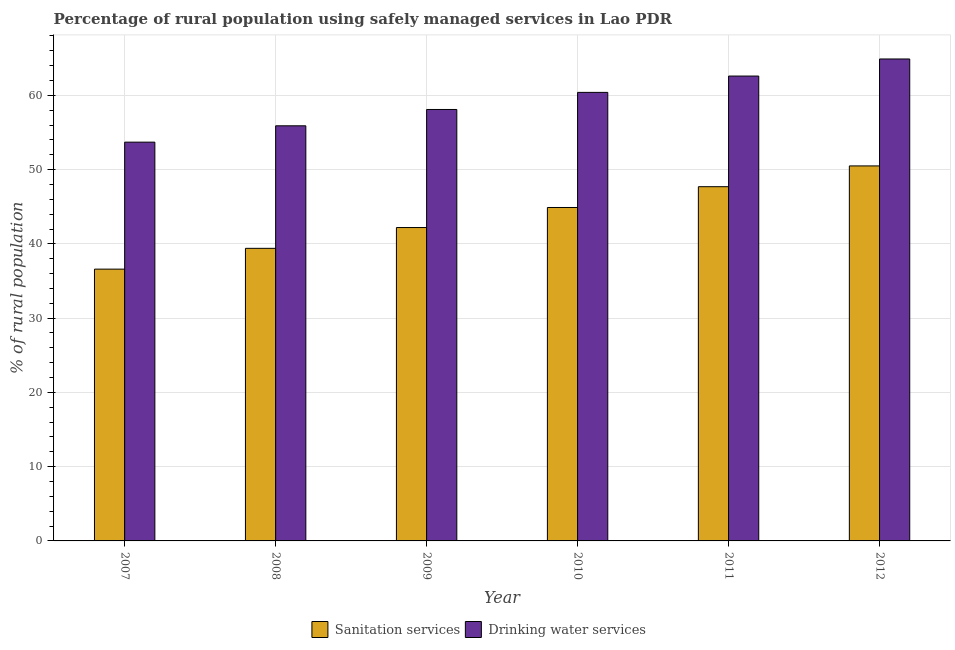How many different coloured bars are there?
Give a very brief answer. 2. Are the number of bars per tick equal to the number of legend labels?
Your answer should be very brief. Yes. Are the number of bars on each tick of the X-axis equal?
Your answer should be very brief. Yes. How many bars are there on the 3rd tick from the left?
Offer a very short reply. 2. What is the label of the 4th group of bars from the left?
Your answer should be compact. 2010. What is the percentage of rural population who used drinking water services in 2009?
Your answer should be compact. 58.1. Across all years, what is the maximum percentage of rural population who used sanitation services?
Your answer should be compact. 50.5. Across all years, what is the minimum percentage of rural population who used sanitation services?
Provide a succinct answer. 36.6. In which year was the percentage of rural population who used drinking water services minimum?
Offer a very short reply. 2007. What is the total percentage of rural population who used drinking water services in the graph?
Offer a very short reply. 355.6. What is the difference between the percentage of rural population who used sanitation services in 2007 and that in 2008?
Make the answer very short. -2.8. What is the difference between the percentage of rural population who used drinking water services in 2008 and the percentage of rural population who used sanitation services in 2007?
Give a very brief answer. 2.2. What is the average percentage of rural population who used drinking water services per year?
Keep it short and to the point. 59.27. In the year 2007, what is the difference between the percentage of rural population who used sanitation services and percentage of rural population who used drinking water services?
Make the answer very short. 0. In how many years, is the percentage of rural population who used sanitation services greater than 40 %?
Make the answer very short. 4. What is the ratio of the percentage of rural population who used sanitation services in 2008 to that in 2010?
Keep it short and to the point. 0.88. Is the percentage of rural population who used sanitation services in 2008 less than that in 2011?
Offer a very short reply. Yes. What is the difference between the highest and the second highest percentage of rural population who used sanitation services?
Give a very brief answer. 2.8. What is the difference between the highest and the lowest percentage of rural population who used sanitation services?
Ensure brevity in your answer.  13.9. In how many years, is the percentage of rural population who used drinking water services greater than the average percentage of rural population who used drinking water services taken over all years?
Your answer should be compact. 3. What does the 2nd bar from the left in 2011 represents?
Offer a terse response. Drinking water services. What does the 1st bar from the right in 2008 represents?
Give a very brief answer. Drinking water services. Are all the bars in the graph horizontal?
Offer a terse response. No. How many years are there in the graph?
Give a very brief answer. 6. Are the values on the major ticks of Y-axis written in scientific E-notation?
Your response must be concise. No. How many legend labels are there?
Give a very brief answer. 2. What is the title of the graph?
Keep it short and to the point. Percentage of rural population using safely managed services in Lao PDR. What is the label or title of the X-axis?
Your answer should be very brief. Year. What is the label or title of the Y-axis?
Provide a succinct answer. % of rural population. What is the % of rural population in Sanitation services in 2007?
Your answer should be compact. 36.6. What is the % of rural population in Drinking water services in 2007?
Your answer should be very brief. 53.7. What is the % of rural population of Sanitation services in 2008?
Offer a very short reply. 39.4. What is the % of rural population in Drinking water services in 2008?
Keep it short and to the point. 55.9. What is the % of rural population in Sanitation services in 2009?
Provide a short and direct response. 42.2. What is the % of rural population in Drinking water services in 2009?
Provide a short and direct response. 58.1. What is the % of rural population of Sanitation services in 2010?
Your answer should be very brief. 44.9. What is the % of rural population in Drinking water services in 2010?
Ensure brevity in your answer.  60.4. What is the % of rural population in Sanitation services in 2011?
Your response must be concise. 47.7. What is the % of rural population of Drinking water services in 2011?
Keep it short and to the point. 62.6. What is the % of rural population of Sanitation services in 2012?
Offer a terse response. 50.5. What is the % of rural population in Drinking water services in 2012?
Your answer should be very brief. 64.9. Across all years, what is the maximum % of rural population in Sanitation services?
Provide a succinct answer. 50.5. Across all years, what is the maximum % of rural population in Drinking water services?
Provide a succinct answer. 64.9. Across all years, what is the minimum % of rural population in Sanitation services?
Provide a succinct answer. 36.6. Across all years, what is the minimum % of rural population in Drinking water services?
Keep it short and to the point. 53.7. What is the total % of rural population in Sanitation services in the graph?
Keep it short and to the point. 261.3. What is the total % of rural population in Drinking water services in the graph?
Your answer should be compact. 355.6. What is the difference between the % of rural population in Drinking water services in 2007 and that in 2008?
Offer a very short reply. -2.2. What is the difference between the % of rural population in Sanitation services in 2007 and that in 2009?
Offer a terse response. -5.6. What is the difference between the % of rural population in Drinking water services in 2007 and that in 2009?
Your answer should be very brief. -4.4. What is the difference between the % of rural population in Sanitation services in 2007 and that in 2010?
Offer a very short reply. -8.3. What is the difference between the % of rural population in Drinking water services in 2007 and that in 2010?
Ensure brevity in your answer.  -6.7. What is the difference between the % of rural population of Sanitation services in 2007 and that in 2011?
Make the answer very short. -11.1. What is the difference between the % of rural population of Drinking water services in 2007 and that in 2011?
Your answer should be compact. -8.9. What is the difference between the % of rural population of Sanitation services in 2007 and that in 2012?
Provide a short and direct response. -13.9. What is the difference between the % of rural population in Drinking water services in 2007 and that in 2012?
Make the answer very short. -11.2. What is the difference between the % of rural population in Sanitation services in 2008 and that in 2009?
Give a very brief answer. -2.8. What is the difference between the % of rural population of Drinking water services in 2008 and that in 2009?
Ensure brevity in your answer.  -2.2. What is the difference between the % of rural population of Sanitation services in 2008 and that in 2010?
Offer a terse response. -5.5. What is the difference between the % of rural population in Drinking water services in 2008 and that in 2011?
Make the answer very short. -6.7. What is the difference between the % of rural population in Sanitation services in 2008 and that in 2012?
Your answer should be compact. -11.1. What is the difference between the % of rural population of Drinking water services in 2009 and that in 2010?
Provide a short and direct response. -2.3. What is the difference between the % of rural population in Drinking water services in 2009 and that in 2011?
Offer a terse response. -4.5. What is the difference between the % of rural population in Sanitation services in 2010 and that in 2012?
Provide a succinct answer. -5.6. What is the difference between the % of rural population of Drinking water services in 2010 and that in 2012?
Give a very brief answer. -4.5. What is the difference between the % of rural population of Sanitation services in 2007 and the % of rural population of Drinking water services in 2008?
Make the answer very short. -19.3. What is the difference between the % of rural population of Sanitation services in 2007 and the % of rural population of Drinking water services in 2009?
Give a very brief answer. -21.5. What is the difference between the % of rural population of Sanitation services in 2007 and the % of rural population of Drinking water services in 2010?
Provide a succinct answer. -23.8. What is the difference between the % of rural population of Sanitation services in 2007 and the % of rural population of Drinking water services in 2011?
Provide a short and direct response. -26. What is the difference between the % of rural population in Sanitation services in 2007 and the % of rural population in Drinking water services in 2012?
Keep it short and to the point. -28.3. What is the difference between the % of rural population of Sanitation services in 2008 and the % of rural population of Drinking water services in 2009?
Offer a terse response. -18.7. What is the difference between the % of rural population of Sanitation services in 2008 and the % of rural population of Drinking water services in 2011?
Give a very brief answer. -23.2. What is the difference between the % of rural population of Sanitation services in 2008 and the % of rural population of Drinking water services in 2012?
Keep it short and to the point. -25.5. What is the difference between the % of rural population in Sanitation services in 2009 and the % of rural population in Drinking water services in 2010?
Your response must be concise. -18.2. What is the difference between the % of rural population of Sanitation services in 2009 and the % of rural population of Drinking water services in 2011?
Keep it short and to the point. -20.4. What is the difference between the % of rural population of Sanitation services in 2009 and the % of rural population of Drinking water services in 2012?
Your response must be concise. -22.7. What is the difference between the % of rural population in Sanitation services in 2010 and the % of rural population in Drinking water services in 2011?
Provide a succinct answer. -17.7. What is the difference between the % of rural population of Sanitation services in 2011 and the % of rural population of Drinking water services in 2012?
Give a very brief answer. -17.2. What is the average % of rural population in Sanitation services per year?
Your response must be concise. 43.55. What is the average % of rural population of Drinking water services per year?
Offer a terse response. 59.27. In the year 2007, what is the difference between the % of rural population in Sanitation services and % of rural population in Drinking water services?
Keep it short and to the point. -17.1. In the year 2008, what is the difference between the % of rural population in Sanitation services and % of rural population in Drinking water services?
Keep it short and to the point. -16.5. In the year 2009, what is the difference between the % of rural population of Sanitation services and % of rural population of Drinking water services?
Make the answer very short. -15.9. In the year 2010, what is the difference between the % of rural population of Sanitation services and % of rural population of Drinking water services?
Your response must be concise. -15.5. In the year 2011, what is the difference between the % of rural population in Sanitation services and % of rural population in Drinking water services?
Ensure brevity in your answer.  -14.9. In the year 2012, what is the difference between the % of rural population in Sanitation services and % of rural population in Drinking water services?
Make the answer very short. -14.4. What is the ratio of the % of rural population in Sanitation services in 2007 to that in 2008?
Keep it short and to the point. 0.93. What is the ratio of the % of rural population in Drinking water services in 2007 to that in 2008?
Provide a succinct answer. 0.96. What is the ratio of the % of rural population in Sanitation services in 2007 to that in 2009?
Your answer should be very brief. 0.87. What is the ratio of the % of rural population in Drinking water services in 2007 to that in 2009?
Make the answer very short. 0.92. What is the ratio of the % of rural population in Sanitation services in 2007 to that in 2010?
Give a very brief answer. 0.82. What is the ratio of the % of rural population in Drinking water services in 2007 to that in 2010?
Your response must be concise. 0.89. What is the ratio of the % of rural population in Sanitation services in 2007 to that in 2011?
Your answer should be very brief. 0.77. What is the ratio of the % of rural population of Drinking water services in 2007 to that in 2011?
Make the answer very short. 0.86. What is the ratio of the % of rural population in Sanitation services in 2007 to that in 2012?
Offer a terse response. 0.72. What is the ratio of the % of rural population in Drinking water services in 2007 to that in 2012?
Make the answer very short. 0.83. What is the ratio of the % of rural population in Sanitation services in 2008 to that in 2009?
Offer a terse response. 0.93. What is the ratio of the % of rural population of Drinking water services in 2008 to that in 2009?
Keep it short and to the point. 0.96. What is the ratio of the % of rural population in Sanitation services in 2008 to that in 2010?
Offer a terse response. 0.88. What is the ratio of the % of rural population of Drinking water services in 2008 to that in 2010?
Keep it short and to the point. 0.93. What is the ratio of the % of rural population of Sanitation services in 2008 to that in 2011?
Provide a succinct answer. 0.83. What is the ratio of the % of rural population of Drinking water services in 2008 to that in 2011?
Make the answer very short. 0.89. What is the ratio of the % of rural population in Sanitation services in 2008 to that in 2012?
Provide a succinct answer. 0.78. What is the ratio of the % of rural population in Drinking water services in 2008 to that in 2012?
Offer a terse response. 0.86. What is the ratio of the % of rural population of Sanitation services in 2009 to that in 2010?
Offer a terse response. 0.94. What is the ratio of the % of rural population of Drinking water services in 2009 to that in 2010?
Provide a short and direct response. 0.96. What is the ratio of the % of rural population in Sanitation services in 2009 to that in 2011?
Offer a very short reply. 0.88. What is the ratio of the % of rural population in Drinking water services in 2009 to that in 2011?
Keep it short and to the point. 0.93. What is the ratio of the % of rural population in Sanitation services in 2009 to that in 2012?
Your response must be concise. 0.84. What is the ratio of the % of rural population of Drinking water services in 2009 to that in 2012?
Ensure brevity in your answer.  0.9. What is the ratio of the % of rural population of Sanitation services in 2010 to that in 2011?
Your answer should be very brief. 0.94. What is the ratio of the % of rural population in Drinking water services in 2010 to that in 2011?
Offer a very short reply. 0.96. What is the ratio of the % of rural population of Sanitation services in 2010 to that in 2012?
Offer a very short reply. 0.89. What is the ratio of the % of rural population of Drinking water services in 2010 to that in 2012?
Ensure brevity in your answer.  0.93. What is the ratio of the % of rural population of Sanitation services in 2011 to that in 2012?
Keep it short and to the point. 0.94. What is the ratio of the % of rural population of Drinking water services in 2011 to that in 2012?
Your answer should be very brief. 0.96. What is the difference between the highest and the lowest % of rural population of Sanitation services?
Your answer should be very brief. 13.9. 